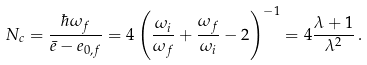<formula> <loc_0><loc_0><loc_500><loc_500>N _ { c } = \frac { \hbar { \omega } _ { f } } { \bar { e } - e _ { 0 , f } } = 4 \left ( \frac { \omega _ { i } } { \omega _ { f } } + \frac { \omega _ { f } } { \omega _ { i } } - 2 \right ) ^ { - 1 } = 4 \frac { \lambda + 1 } { \lambda ^ { 2 } } \, .</formula> 